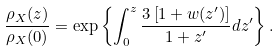<formula> <loc_0><loc_0><loc_500><loc_500>\frac { \rho _ { X } ( z ) } { \rho _ { X } ( 0 ) } = \exp \left \{ \int _ { 0 } ^ { z } \frac { 3 \left [ 1 + w ( z ^ { \prime } ) \right ] } { 1 + z ^ { \prime } } d z ^ { \prime } \right \} .</formula> 